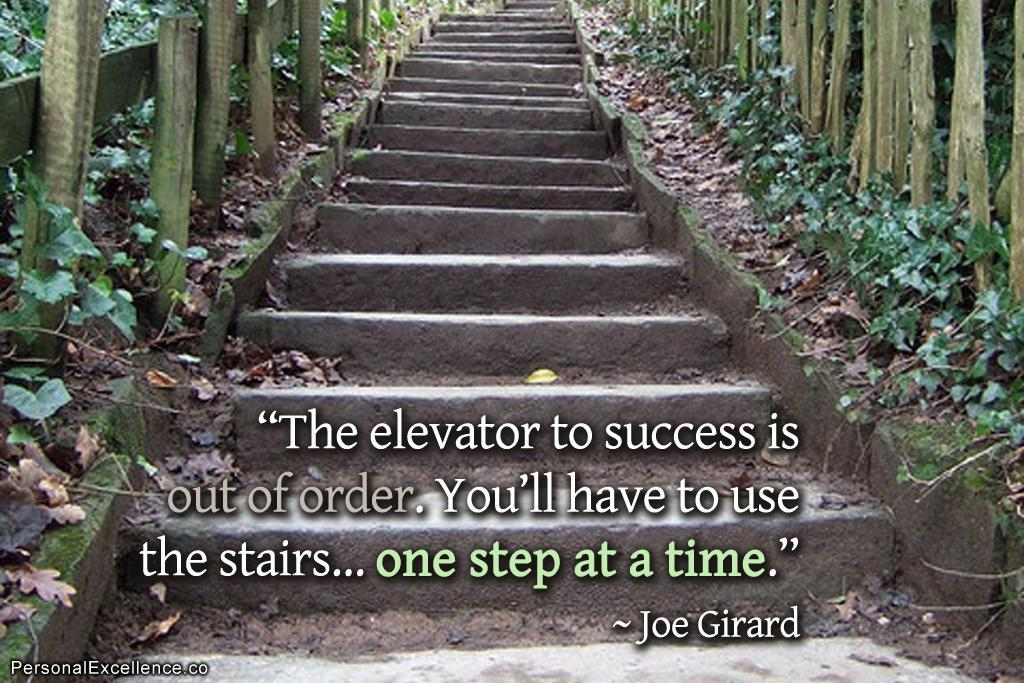What type of structure can be seen in the image? There are steps in the image. What surrounds the steps on both sides? There is wooden fencing on both sides of the steps. What type of natural elements are present in the image? There are plants and dry leaves in the image. What is written or displayed in front of the steps? There is a quotation and a watermark in front of the steps. What type of fowl can be seen walking on the steps in the image? There are no fowl or chickens present in the image; it only features steps, wooden fencing, plants, dry leaves, a quotation, and a watermark. 